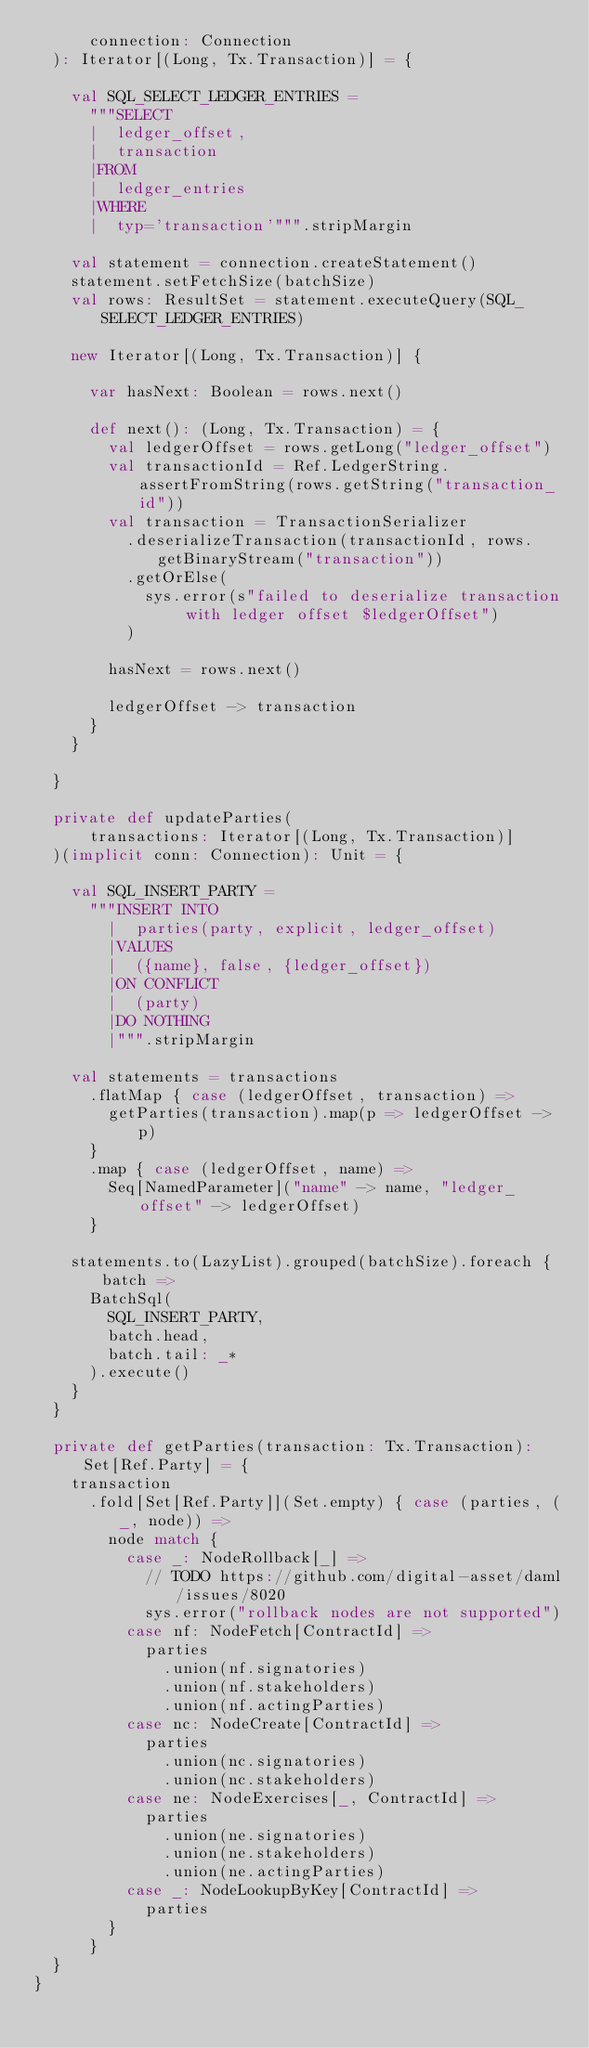Convert code to text. <code><loc_0><loc_0><loc_500><loc_500><_Scala_>      connection: Connection
  ): Iterator[(Long, Tx.Transaction)] = {

    val SQL_SELECT_LEDGER_ENTRIES =
      """SELECT
      |  ledger_offset,
      |  transaction
      |FROM
      |  ledger_entries
      |WHERE
      |  typ='transaction'""".stripMargin

    val statement = connection.createStatement()
    statement.setFetchSize(batchSize)
    val rows: ResultSet = statement.executeQuery(SQL_SELECT_LEDGER_ENTRIES)

    new Iterator[(Long, Tx.Transaction)] {

      var hasNext: Boolean = rows.next()

      def next(): (Long, Tx.Transaction) = {
        val ledgerOffset = rows.getLong("ledger_offset")
        val transactionId = Ref.LedgerString.assertFromString(rows.getString("transaction_id"))
        val transaction = TransactionSerializer
          .deserializeTransaction(transactionId, rows.getBinaryStream("transaction"))
          .getOrElse(
            sys.error(s"failed to deserialize transaction with ledger offset $ledgerOffset")
          )

        hasNext = rows.next()

        ledgerOffset -> transaction
      }
    }

  }

  private def updateParties(
      transactions: Iterator[(Long, Tx.Transaction)]
  )(implicit conn: Connection): Unit = {

    val SQL_INSERT_PARTY =
      """INSERT INTO
        |  parties(party, explicit, ledger_offset)
        |VALUES
        |  ({name}, false, {ledger_offset})
        |ON CONFLICT
        |  (party)
        |DO NOTHING
        |""".stripMargin

    val statements = transactions
      .flatMap { case (ledgerOffset, transaction) =>
        getParties(transaction).map(p => ledgerOffset -> p)
      }
      .map { case (ledgerOffset, name) =>
        Seq[NamedParameter]("name" -> name, "ledger_offset" -> ledgerOffset)
      }

    statements.to(LazyList).grouped(batchSize).foreach { batch =>
      BatchSql(
        SQL_INSERT_PARTY,
        batch.head,
        batch.tail: _*
      ).execute()
    }
  }

  private def getParties(transaction: Tx.Transaction): Set[Ref.Party] = {
    transaction
      .fold[Set[Ref.Party]](Set.empty) { case (parties, (_, node)) =>
        node match {
          case _: NodeRollback[_] =>
            // TODO https://github.com/digital-asset/daml/issues/8020
            sys.error("rollback nodes are not supported")
          case nf: NodeFetch[ContractId] =>
            parties
              .union(nf.signatories)
              .union(nf.stakeholders)
              .union(nf.actingParties)
          case nc: NodeCreate[ContractId] =>
            parties
              .union(nc.signatories)
              .union(nc.stakeholders)
          case ne: NodeExercises[_, ContractId] =>
            parties
              .union(ne.signatories)
              .union(ne.stakeholders)
              .union(ne.actingParties)
          case _: NodeLookupByKey[ContractId] =>
            parties
        }
      }
  }
}
</code> 